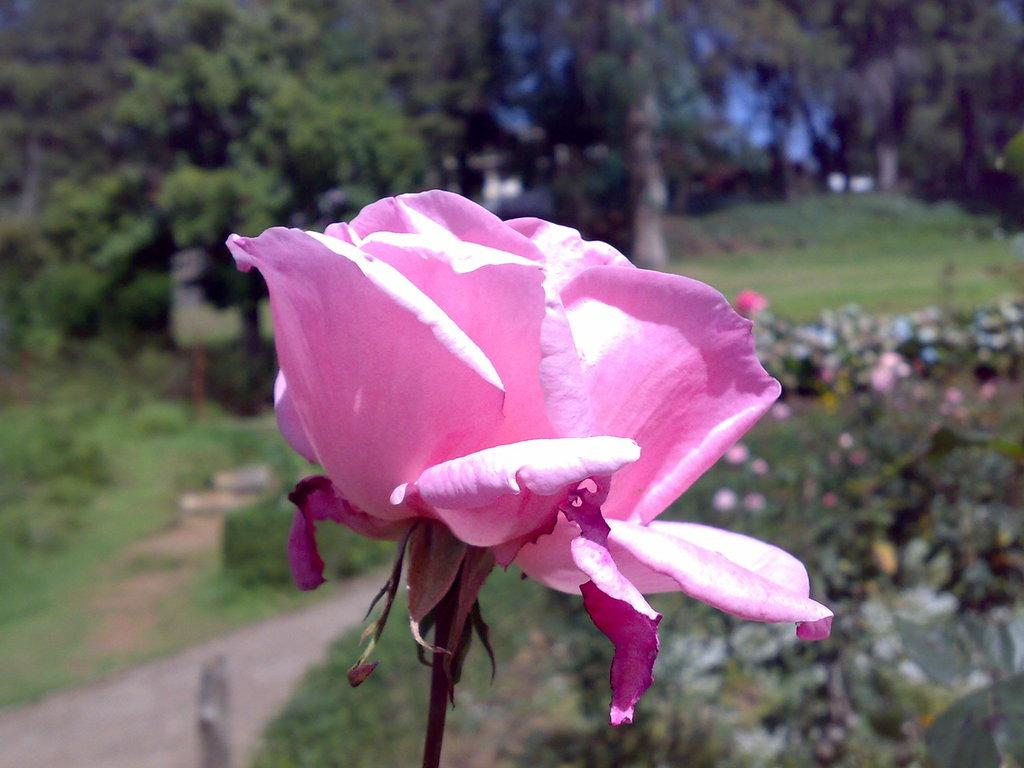What type of vegetation can be seen in the background of the image? There are trees and grass in the background of the image. What is located on the right side of the image? There are flower plants on the right side of the image. What is the main focus of the image? The image is mainly highlighted by a pink rose. What type of treatment is the judge receiving in the image? There is no judge or any treatment present in the image. 